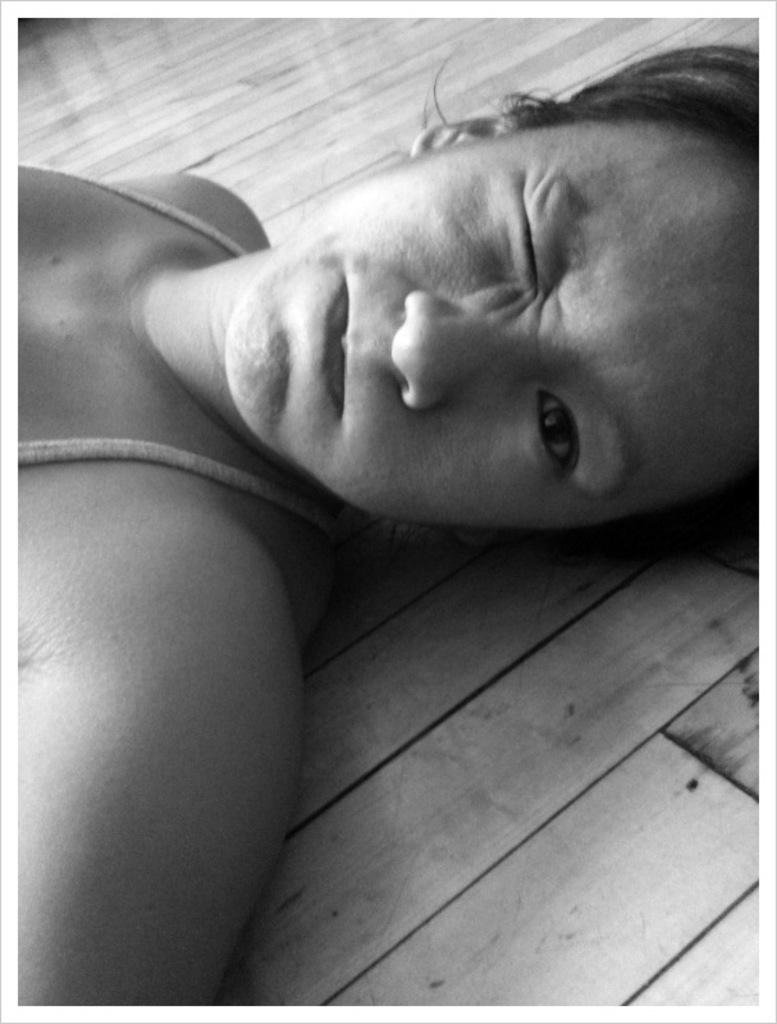Who is the main subject in the image? There is a woman in the image. What is the woman doing in the image? The woman is lying on a wooden surface. What type of health benefits does the scene in the image provide? The provided facts do not mention any health benefits or a specific scene, so it is not possible to answer this question. 